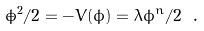Convert formula to latex. <formula><loc_0><loc_0><loc_500><loc_500>\dot { \phi } ^ { 2 } / 2 = - V ( \phi ) = \lambda \phi ^ { n } / 2 \ .</formula> 